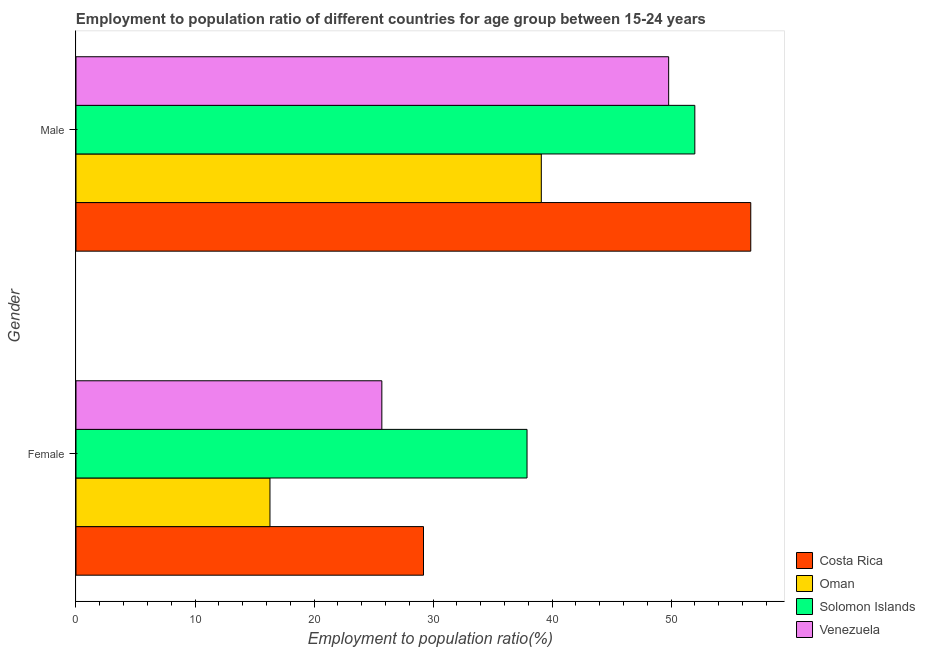How many groups of bars are there?
Offer a very short reply. 2. Are the number of bars per tick equal to the number of legend labels?
Your answer should be very brief. Yes. Are the number of bars on each tick of the Y-axis equal?
Your answer should be very brief. Yes. How many bars are there on the 1st tick from the top?
Offer a terse response. 4. What is the label of the 2nd group of bars from the top?
Provide a short and direct response. Female. What is the employment to population ratio(male) in Venezuela?
Keep it short and to the point. 49.8. Across all countries, what is the maximum employment to population ratio(male)?
Ensure brevity in your answer.  56.7. Across all countries, what is the minimum employment to population ratio(female)?
Make the answer very short. 16.3. In which country was the employment to population ratio(female) maximum?
Your response must be concise. Solomon Islands. In which country was the employment to population ratio(female) minimum?
Your answer should be very brief. Oman. What is the total employment to population ratio(female) in the graph?
Provide a succinct answer. 109.1. What is the difference between the employment to population ratio(male) in Venezuela and that in Costa Rica?
Your answer should be compact. -6.9. What is the difference between the employment to population ratio(male) in Venezuela and the employment to population ratio(female) in Solomon Islands?
Your response must be concise. 11.9. What is the average employment to population ratio(female) per country?
Keep it short and to the point. 27.28. What is the difference between the employment to population ratio(female) and employment to population ratio(male) in Oman?
Offer a terse response. -22.8. In how many countries, is the employment to population ratio(male) greater than 32 %?
Provide a succinct answer. 4. What is the ratio of the employment to population ratio(female) in Oman to that in Costa Rica?
Offer a terse response. 0.56. What does the 4th bar from the top in Female represents?
Make the answer very short. Costa Rica. What does the 1st bar from the bottom in Male represents?
Keep it short and to the point. Costa Rica. How many bars are there?
Provide a succinct answer. 8. How many countries are there in the graph?
Make the answer very short. 4. What is the difference between two consecutive major ticks on the X-axis?
Make the answer very short. 10. Does the graph contain grids?
Offer a terse response. No. What is the title of the graph?
Make the answer very short. Employment to population ratio of different countries for age group between 15-24 years. Does "St. Vincent and the Grenadines" appear as one of the legend labels in the graph?
Provide a short and direct response. No. What is the label or title of the Y-axis?
Keep it short and to the point. Gender. What is the Employment to population ratio(%) of Costa Rica in Female?
Make the answer very short. 29.2. What is the Employment to population ratio(%) in Oman in Female?
Provide a short and direct response. 16.3. What is the Employment to population ratio(%) of Solomon Islands in Female?
Offer a very short reply. 37.9. What is the Employment to population ratio(%) of Venezuela in Female?
Offer a terse response. 25.7. What is the Employment to population ratio(%) of Costa Rica in Male?
Keep it short and to the point. 56.7. What is the Employment to population ratio(%) of Oman in Male?
Offer a very short reply. 39.1. What is the Employment to population ratio(%) of Solomon Islands in Male?
Keep it short and to the point. 52. What is the Employment to population ratio(%) of Venezuela in Male?
Your response must be concise. 49.8. Across all Gender, what is the maximum Employment to population ratio(%) in Costa Rica?
Keep it short and to the point. 56.7. Across all Gender, what is the maximum Employment to population ratio(%) of Oman?
Offer a very short reply. 39.1. Across all Gender, what is the maximum Employment to population ratio(%) of Solomon Islands?
Your response must be concise. 52. Across all Gender, what is the maximum Employment to population ratio(%) of Venezuela?
Keep it short and to the point. 49.8. Across all Gender, what is the minimum Employment to population ratio(%) of Costa Rica?
Offer a very short reply. 29.2. Across all Gender, what is the minimum Employment to population ratio(%) in Oman?
Provide a succinct answer. 16.3. Across all Gender, what is the minimum Employment to population ratio(%) in Solomon Islands?
Provide a short and direct response. 37.9. Across all Gender, what is the minimum Employment to population ratio(%) in Venezuela?
Keep it short and to the point. 25.7. What is the total Employment to population ratio(%) in Costa Rica in the graph?
Provide a succinct answer. 85.9. What is the total Employment to population ratio(%) of Oman in the graph?
Keep it short and to the point. 55.4. What is the total Employment to population ratio(%) of Solomon Islands in the graph?
Offer a terse response. 89.9. What is the total Employment to population ratio(%) of Venezuela in the graph?
Offer a terse response. 75.5. What is the difference between the Employment to population ratio(%) of Costa Rica in Female and that in Male?
Your answer should be compact. -27.5. What is the difference between the Employment to population ratio(%) of Oman in Female and that in Male?
Your answer should be very brief. -22.8. What is the difference between the Employment to population ratio(%) of Solomon Islands in Female and that in Male?
Offer a terse response. -14.1. What is the difference between the Employment to population ratio(%) of Venezuela in Female and that in Male?
Offer a very short reply. -24.1. What is the difference between the Employment to population ratio(%) of Costa Rica in Female and the Employment to population ratio(%) of Oman in Male?
Your answer should be very brief. -9.9. What is the difference between the Employment to population ratio(%) in Costa Rica in Female and the Employment to population ratio(%) in Solomon Islands in Male?
Offer a terse response. -22.8. What is the difference between the Employment to population ratio(%) of Costa Rica in Female and the Employment to population ratio(%) of Venezuela in Male?
Offer a terse response. -20.6. What is the difference between the Employment to population ratio(%) of Oman in Female and the Employment to population ratio(%) of Solomon Islands in Male?
Your answer should be very brief. -35.7. What is the difference between the Employment to population ratio(%) of Oman in Female and the Employment to population ratio(%) of Venezuela in Male?
Make the answer very short. -33.5. What is the difference between the Employment to population ratio(%) in Solomon Islands in Female and the Employment to population ratio(%) in Venezuela in Male?
Offer a very short reply. -11.9. What is the average Employment to population ratio(%) in Costa Rica per Gender?
Ensure brevity in your answer.  42.95. What is the average Employment to population ratio(%) of Oman per Gender?
Provide a succinct answer. 27.7. What is the average Employment to population ratio(%) in Solomon Islands per Gender?
Your response must be concise. 44.95. What is the average Employment to population ratio(%) of Venezuela per Gender?
Ensure brevity in your answer.  37.75. What is the difference between the Employment to population ratio(%) in Costa Rica and Employment to population ratio(%) in Oman in Female?
Keep it short and to the point. 12.9. What is the difference between the Employment to population ratio(%) in Costa Rica and Employment to population ratio(%) in Solomon Islands in Female?
Ensure brevity in your answer.  -8.7. What is the difference between the Employment to population ratio(%) in Oman and Employment to population ratio(%) in Solomon Islands in Female?
Provide a succinct answer. -21.6. What is the difference between the Employment to population ratio(%) of Oman and Employment to population ratio(%) of Venezuela in Female?
Provide a succinct answer. -9.4. What is the difference between the Employment to population ratio(%) in Solomon Islands and Employment to population ratio(%) in Venezuela in Female?
Your response must be concise. 12.2. What is the difference between the Employment to population ratio(%) of Costa Rica and Employment to population ratio(%) of Solomon Islands in Male?
Your answer should be very brief. 4.7. What is the difference between the Employment to population ratio(%) in Oman and Employment to population ratio(%) in Solomon Islands in Male?
Keep it short and to the point. -12.9. What is the difference between the Employment to population ratio(%) of Solomon Islands and Employment to population ratio(%) of Venezuela in Male?
Provide a short and direct response. 2.2. What is the ratio of the Employment to population ratio(%) of Costa Rica in Female to that in Male?
Offer a terse response. 0.52. What is the ratio of the Employment to population ratio(%) of Oman in Female to that in Male?
Keep it short and to the point. 0.42. What is the ratio of the Employment to population ratio(%) of Solomon Islands in Female to that in Male?
Give a very brief answer. 0.73. What is the ratio of the Employment to population ratio(%) in Venezuela in Female to that in Male?
Your answer should be very brief. 0.52. What is the difference between the highest and the second highest Employment to population ratio(%) of Costa Rica?
Your answer should be very brief. 27.5. What is the difference between the highest and the second highest Employment to population ratio(%) in Oman?
Provide a short and direct response. 22.8. What is the difference between the highest and the second highest Employment to population ratio(%) in Solomon Islands?
Provide a succinct answer. 14.1. What is the difference between the highest and the second highest Employment to population ratio(%) of Venezuela?
Provide a short and direct response. 24.1. What is the difference between the highest and the lowest Employment to population ratio(%) in Costa Rica?
Keep it short and to the point. 27.5. What is the difference between the highest and the lowest Employment to population ratio(%) of Oman?
Your answer should be compact. 22.8. What is the difference between the highest and the lowest Employment to population ratio(%) of Solomon Islands?
Your answer should be very brief. 14.1. What is the difference between the highest and the lowest Employment to population ratio(%) of Venezuela?
Keep it short and to the point. 24.1. 